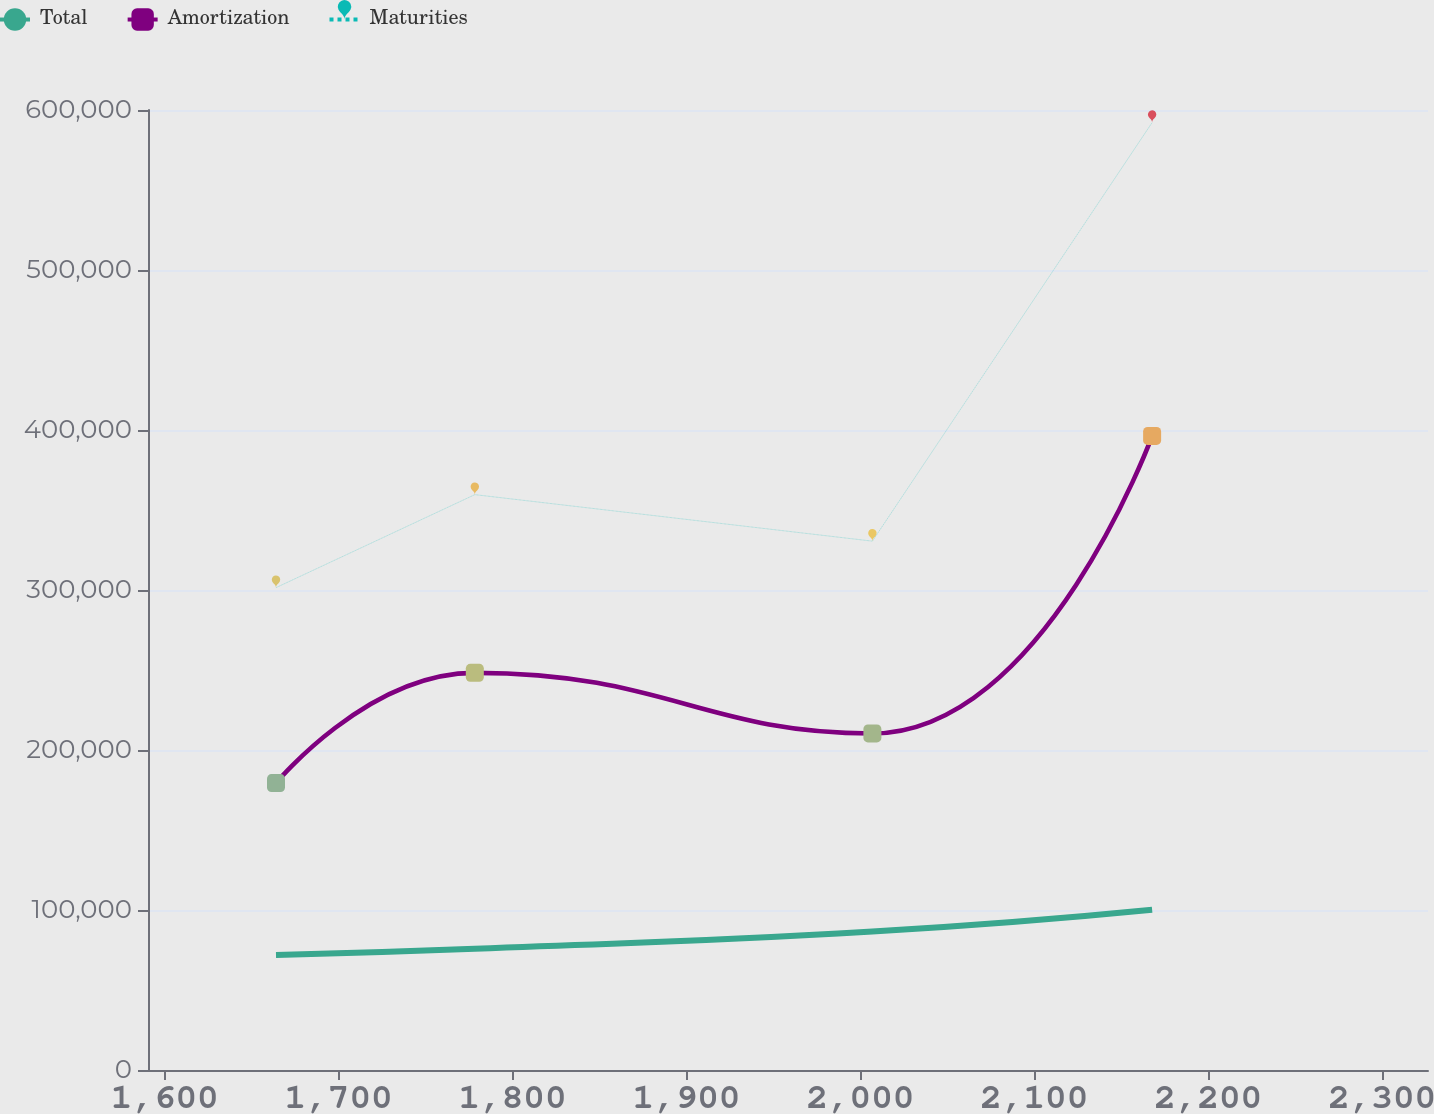Convert chart. <chart><loc_0><loc_0><loc_500><loc_500><line_chart><ecel><fcel>Total<fcel>Amortization<fcel>Maturities<nl><fcel>1664<fcel>71941.4<fcel>179318<fcel>301466<nl><fcel>1778.31<fcel>75779.6<fcel>248222<fcel>359603<nl><fcel>2006.91<fcel>86582.1<fcel>210357<fcel>330534<nl><fcel>2167.74<fcel>100163<fcel>396305<fcel>592151<nl><fcel>2399.96<fcel>68805.6<fcel>489711<fcel>482962<nl></chart> 